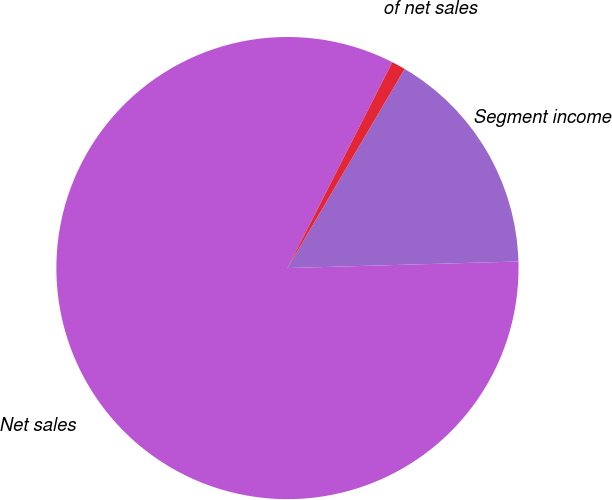Convert chart. <chart><loc_0><loc_0><loc_500><loc_500><pie_chart><fcel>Net sales<fcel>Segment income<fcel>of net sales<nl><fcel>82.95%<fcel>16.08%<fcel>0.97%<nl></chart> 